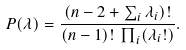<formula> <loc_0><loc_0><loc_500><loc_500>P ( \lambda ) = \frac { ( n - 2 + \sum _ { i } \lambda _ { i } ) ! } { ( n - 1 ) ! \, \prod _ { i } ( \lambda _ { i } ! ) } .</formula> 